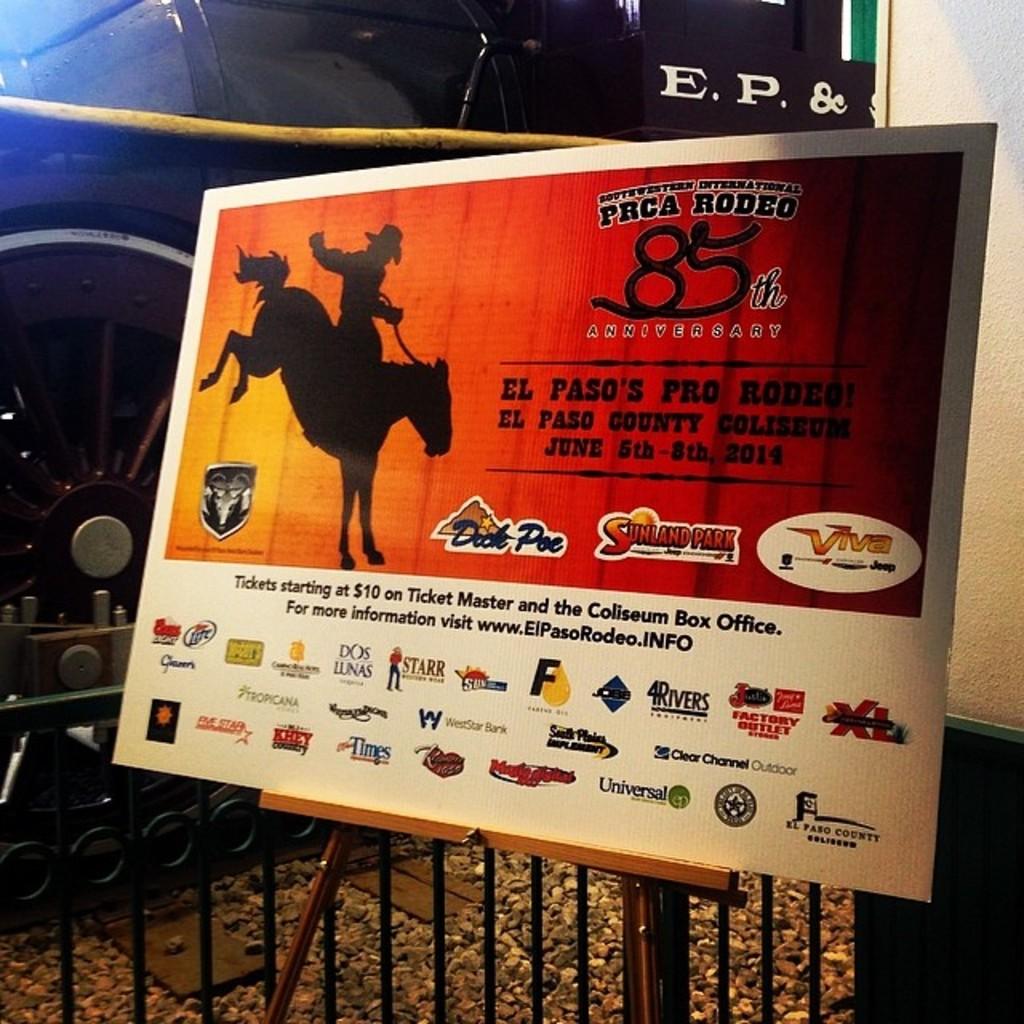What number of rodeo is this?
Offer a very short reply. 85th. What city puts on this rodeo?
Provide a short and direct response. El paso. 